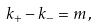<formula> <loc_0><loc_0><loc_500><loc_500>k _ { + } - k _ { - } = { m } \, ,</formula> 